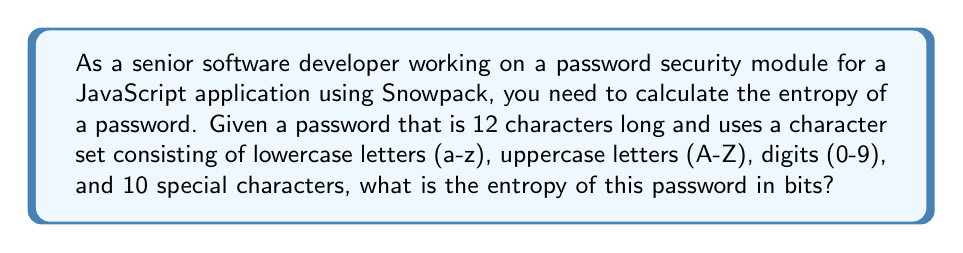Can you answer this question? Let's approach this step-by-step:

1. First, we need to calculate the size of the character set:
   - Lowercase letters: 26
   - Uppercase letters: 26
   - Digits: 10
   - Special characters: 10
   Total: $26 + 26 + 10 + 10 = 72$ characters

2. The formula for password entropy is:
   $$ E = L \log_2(R) $$
   Where:
   $E$ is the entropy in bits
   $L$ is the length of the password
   $R$ is the size of the character set

3. We have:
   $L = 12$ (password length)
   $R = 72$ (character set size)

4. Plugging these values into the formula:
   $$ E = 12 \log_2(72) $$

5. Calculate $\log_2(72)$:
   $$ \log_2(72) \approx 6.1699250014423125 $$

6. Multiply by the password length:
   $$ E = 12 * 6.1699250014423125 \approx 74.03910001730775 $$

7. Round to two decimal places for a practical result:
   $$ E \approx 74.04 \text{ bits} $$
Answer: 74.04 bits 